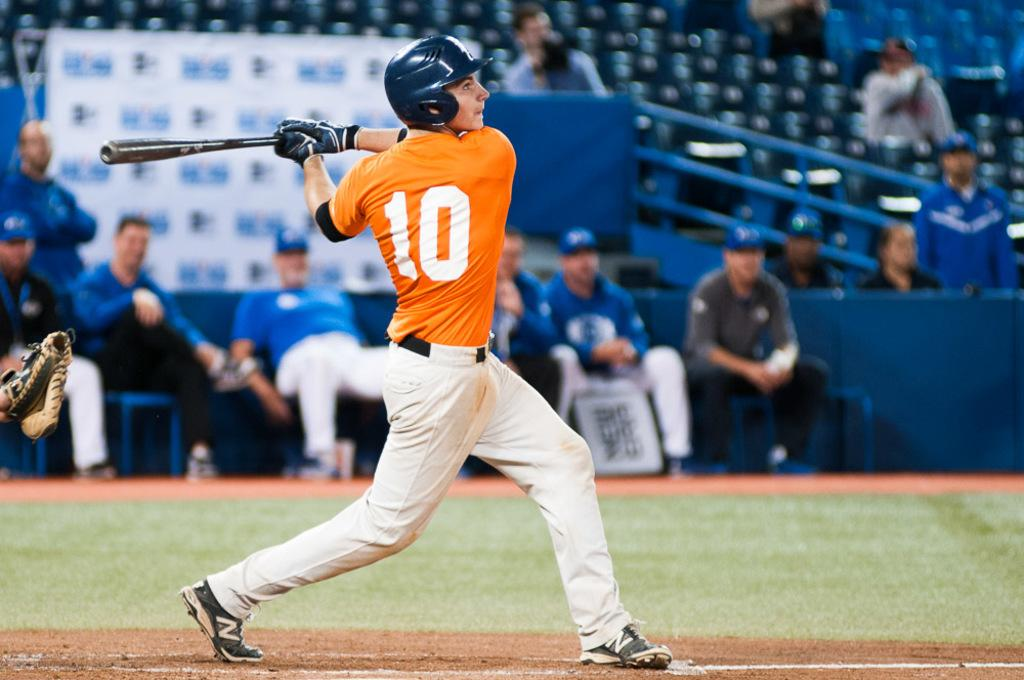Provide a one-sentence caption for the provided image. A guy in a baseball uniform has the number 10 on the back of his jersey. 